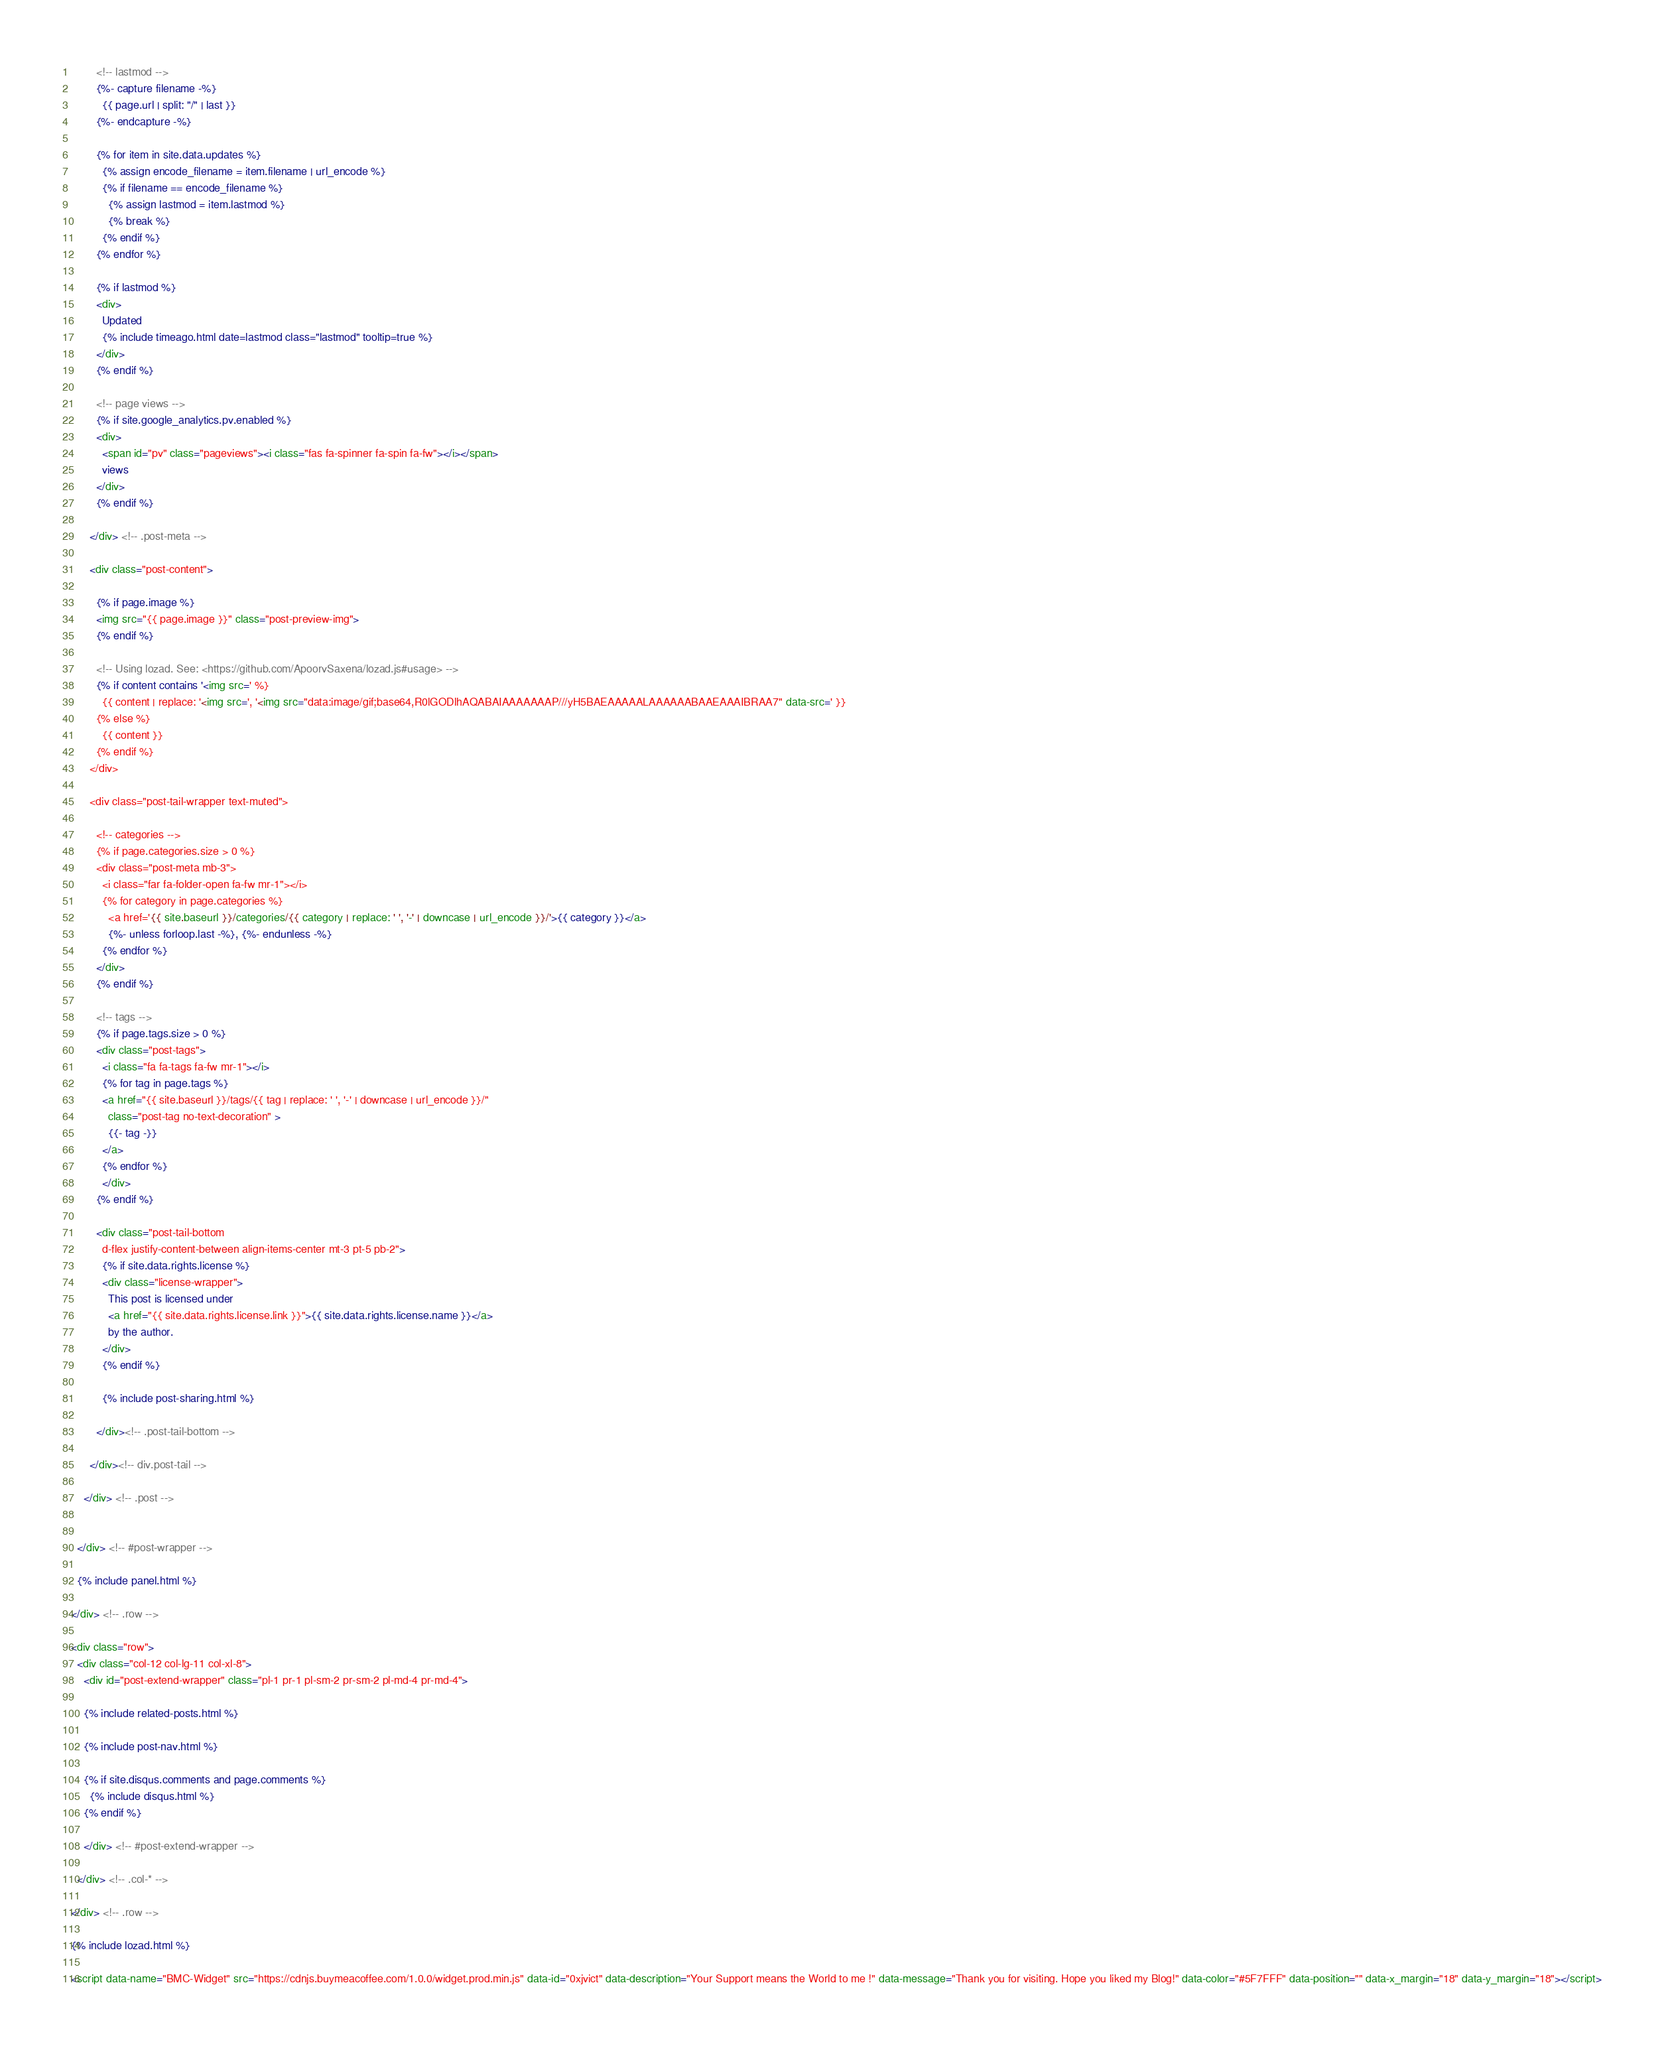<code> <loc_0><loc_0><loc_500><loc_500><_HTML_>        <!-- lastmod -->
        {%- capture filename -%}
          {{ page.url | split: "/" | last }}
        {%- endcapture -%}

        {% for item in site.data.updates %}
          {% assign encode_filename = item.filename | url_encode %}
          {% if filename == encode_filename %}
            {% assign lastmod = item.lastmod %}
            {% break %}
          {% endif %}
        {% endfor %}

        {% if lastmod %}
        <div>
          Updated
          {% include timeago.html date=lastmod class="lastmod" tooltip=true %}
        </div>
        {% endif %}

        <!-- page views -->
        {% if site.google_analytics.pv.enabled %}
        <div>
          <span id="pv" class="pageviews"><i class="fas fa-spinner fa-spin fa-fw"></i></span>
          views
        </div>
        {% endif %}

      </div> <!-- .post-meta -->

      <div class="post-content">

        {% if page.image %}
        <img src="{{ page.image }}" class="post-preview-img">
        {% endif %}

        <!-- Using lozad. See: <https://github.com/ApoorvSaxena/lozad.js#usage> -->
        {% if content contains '<img src=' %}
          {{ content | replace: '<img src=', '<img src="data:image/gif;base64,R0lGODlhAQABAIAAAAAAAP///yH5BAEAAAAALAAAAAABAAEAAAIBRAA7" data-src=' }}
        {% else %}
          {{ content }}
        {% endif %}
      </div>

      <div class="post-tail-wrapper text-muted">

        <!-- categories -->
        {% if page.categories.size > 0 %}
        <div class="post-meta mb-3">
          <i class="far fa-folder-open fa-fw mr-1"></i>
          {% for category in page.categories %}
            <a href='{{ site.baseurl }}/categories/{{ category | replace: ' ', '-' | downcase | url_encode }}/'>{{ category }}</a>
            {%- unless forloop.last -%}, {%- endunless -%}
          {% endfor %}
        </div>
        {% endif %}

        <!-- tags -->
        {% if page.tags.size > 0 %}
        <div class="post-tags">
          <i class="fa fa-tags fa-fw mr-1"></i>
          {% for tag in page.tags %}
          <a href="{{ site.baseurl }}/tags/{{ tag | replace: ' ', '-' | downcase | url_encode }}/"
            class="post-tag no-text-decoration" >
            {{- tag -}}
          </a>
          {% endfor %}
          </div>
        {% endif %}

        <div class="post-tail-bottom
          d-flex justify-content-between align-items-center mt-3 pt-5 pb-2">
          {% if site.data.rights.license %}
          <div class="license-wrapper">
            This post is licensed under
            <a href="{{ site.data.rights.license.link }}">{{ site.data.rights.license.name }}</a>
            by the author.
          </div>
          {% endif %}

          {% include post-sharing.html %}

        </div><!-- .post-tail-bottom -->

      </div><!-- div.post-tail -->

    </div> <!-- .post -->


  </div> <!-- #post-wrapper -->

  {% include panel.html %}

</div> <!-- .row -->

<div class="row">
  <div class="col-12 col-lg-11 col-xl-8">
    <div id="post-extend-wrapper" class="pl-1 pr-1 pl-sm-2 pr-sm-2 pl-md-4 pr-md-4">

    {% include related-posts.html %}

    {% include post-nav.html %}

    {% if site.disqus.comments and page.comments %}
      {% include disqus.html %}
    {% endif %}

    </div> <!-- #post-extend-wrapper -->

  </div> <!-- .col-* -->

</div> <!-- .row -->

{% include lozad.html %}

<script data-name="BMC-Widget" src="https://cdnjs.buymeacoffee.com/1.0.0/widget.prod.min.js" data-id="0xjvict" data-description="Your Support means the World to me !" data-message="Thank you for visiting. Hope you liked my Blog!" data-color="#5F7FFF" data-position="" data-x_margin="18" data-y_margin="18"></script>
</code> 